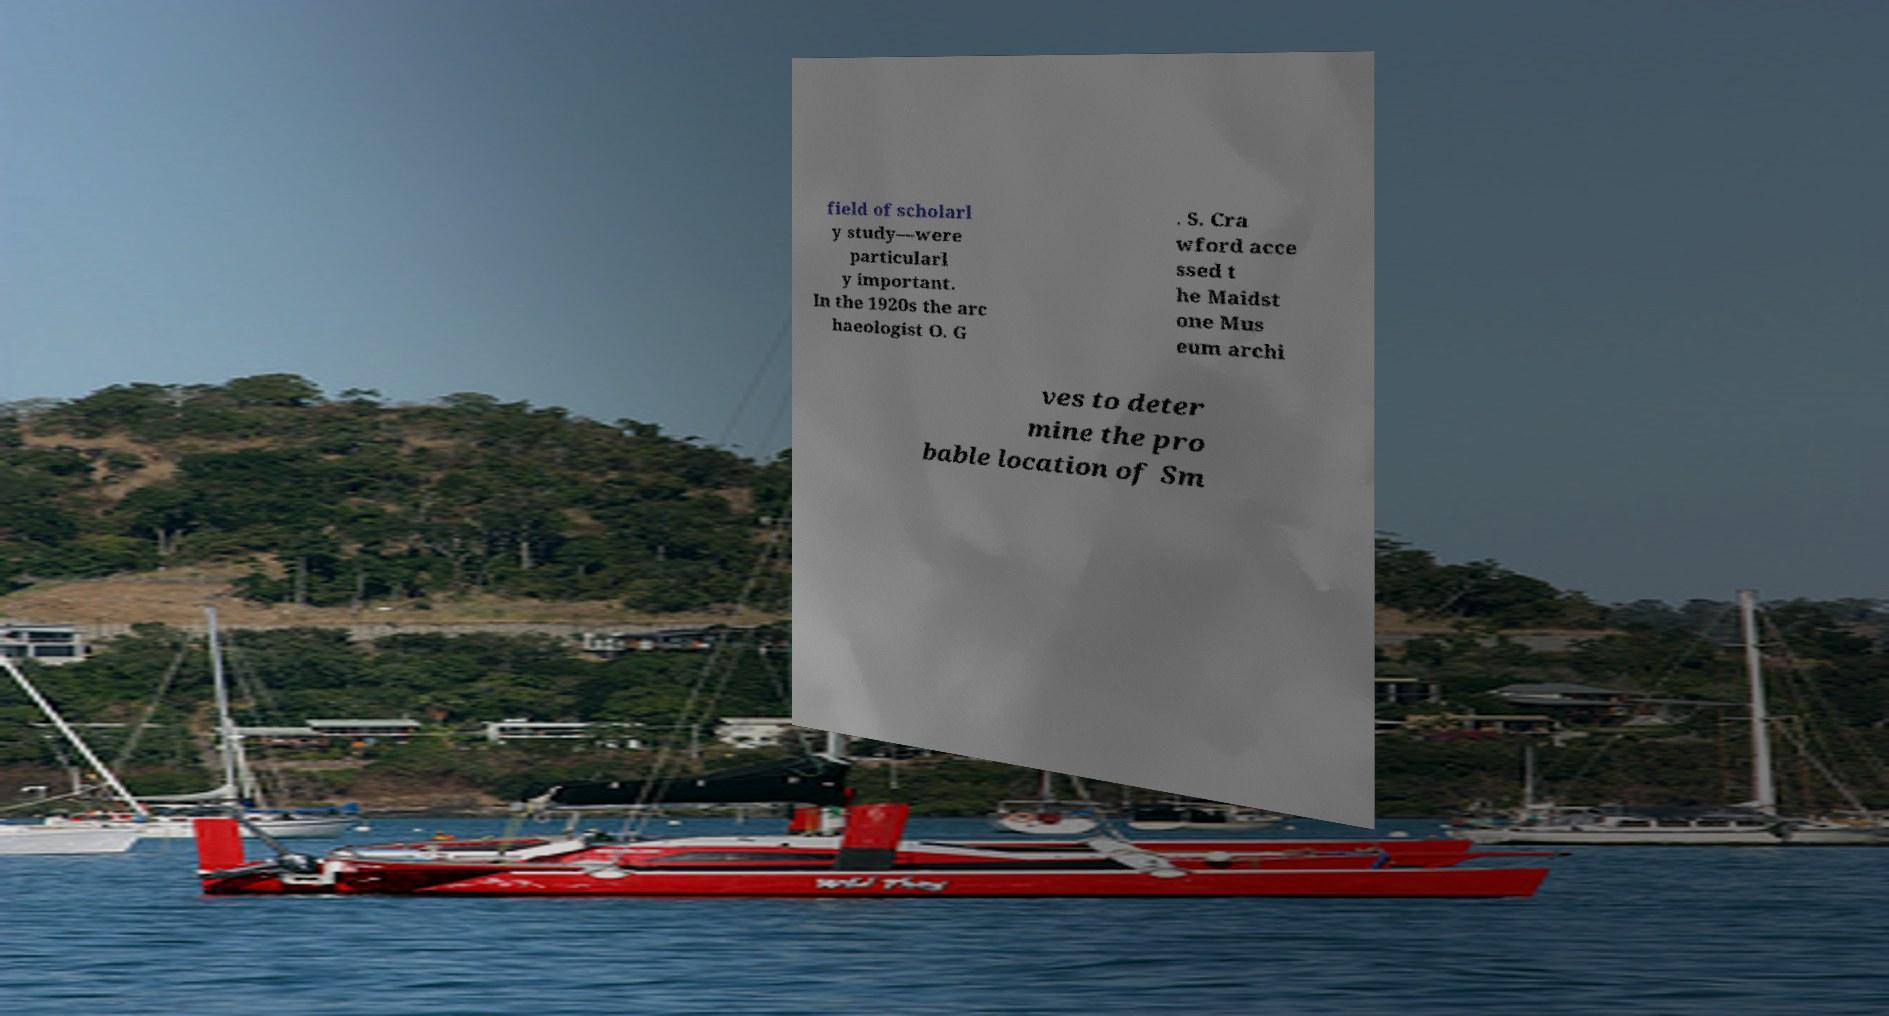Can you accurately transcribe the text from the provided image for me? field of scholarl y study—were particularl y important. In the 1920s the arc haeologist O. G . S. Cra wford acce ssed t he Maidst one Mus eum archi ves to deter mine the pro bable location of Sm 